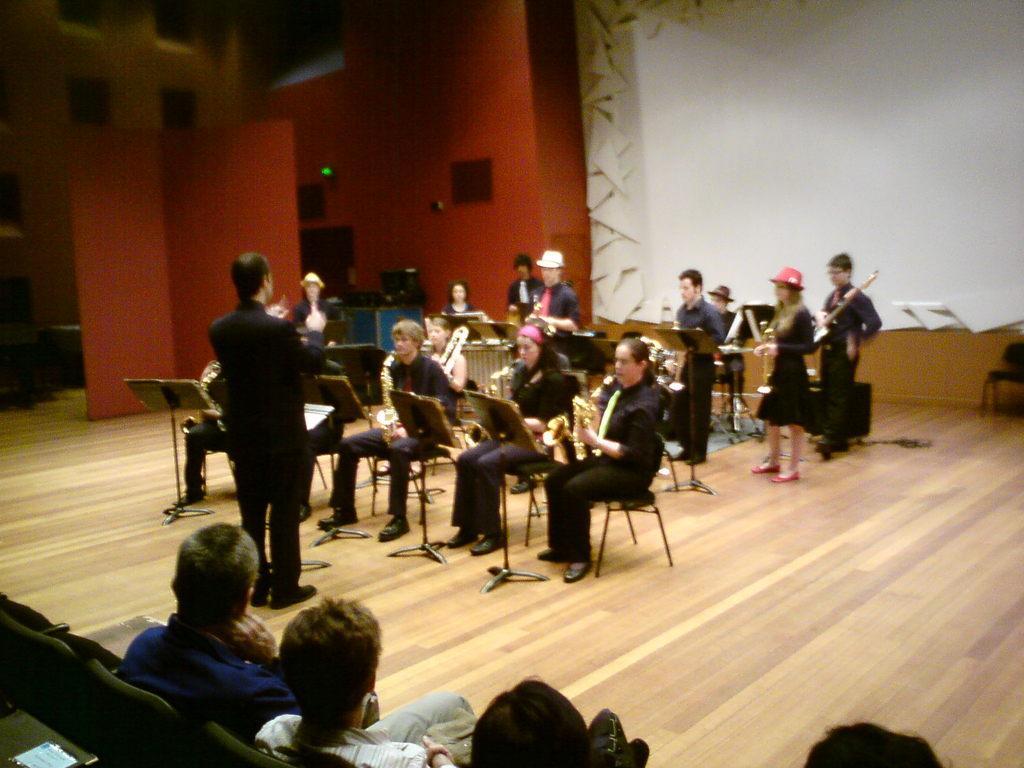Could you give a brief overview of what you see in this image? In this image there are people sitting on chairs and few are standing they are playing musical instruments, in front of them there is a man standing and few people are sitting on chair, in the background there is a wall for that wall there is a white color curtain. 